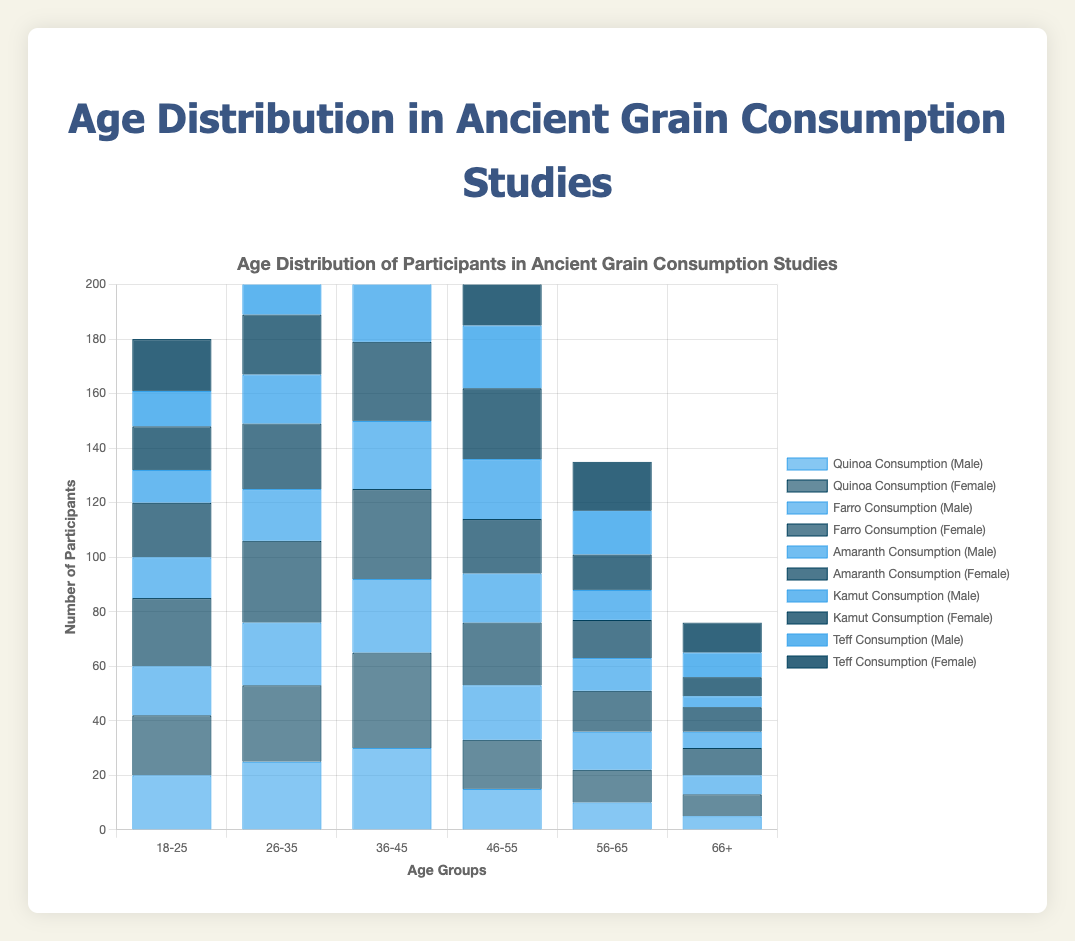Which age group has the highest number of participants in Quinoa Consumption studies? Look at the bars for Quinoa Consumption in each age group. The highest is the '36-45' age group with 65 participants (30 Males + 35 Females).
Answer: 36-45 How does the number of female participants in the 66+ age group for Farro Consumption compare to those in Kamut Consumption? Look at the '66+' age group. For Farro Consumption, it is 10 females. For Kamut Consumption, it is 7 females. 10 is greater than 7.
Answer: Greater What is the total number of participants in the '46-55' age group for Teff Consumption? Add the number of male and female participants in the '46-55' age group for Teff Consumption: 23 (Male) + 28 (Female) = 51
Answer: 51 Compare the number of male participants aged '18-25' across all studies. Which study has the lowest number of male participants in this age group? The numbers are: Quinoa - 20, Farro - 18, Amaranth - 15, Kamut - 12, Teff - 13. The lowest number is for Kamut.
Answer: Kamut What is the average number of female participants in the '26-35' age group across all studies? The numbers for each study are Quinoa - 28, Farro - 30, Amaranth - 24, Kamut - 22, Teff - 27. The sum is 28 + 30 + 24 + 22 + 27 = 131. The average is 131 / 5 = 26.2
Answer: 26.2 What is the difference in the total number of male and female participants for Amaranth Consumption in the '36-45' age group? The number of male participants is 25 and female participants is 29. The difference is 29 - 25 = 4.
Answer: 4 Which study has the highest number of participants in the '56-65' age group? Add the number of male and female participants for each study in the '56-65' age group. The highest total is for Teff Consumption: 16 (Male) + 18 (Female) = 34.
Answer: Teff Consumption What is the combined total number of participants aged '18-25' for Kamut and Teff Consumption? Total number of participants for Kamut: 12 (Male) + 16 (Female) = 28, and for Teff: 13 (Male) + 19 (Female) = 32. Combined total is 28 + 32 = 60.
Answer: 60 Which age group has the smallest number of male participants in the Farro Consumption study? Look at each age group for male participants in Farro Consumption: 18-25 (18), 26-35 (23), 36-45 (27), 46-55 (20), 56-65 (14), 66+ (7). The smallest number is in the '66+' age group.
Answer: 66+ How does the number of female participants in the '36-45' age group for Quinoa Consumption compare to Farro Consumption? For the '36-45' age group, the number of female participants is 35 for Quinoa and 33 for Farro. 35 is greater than 33.
Answer: Greater 